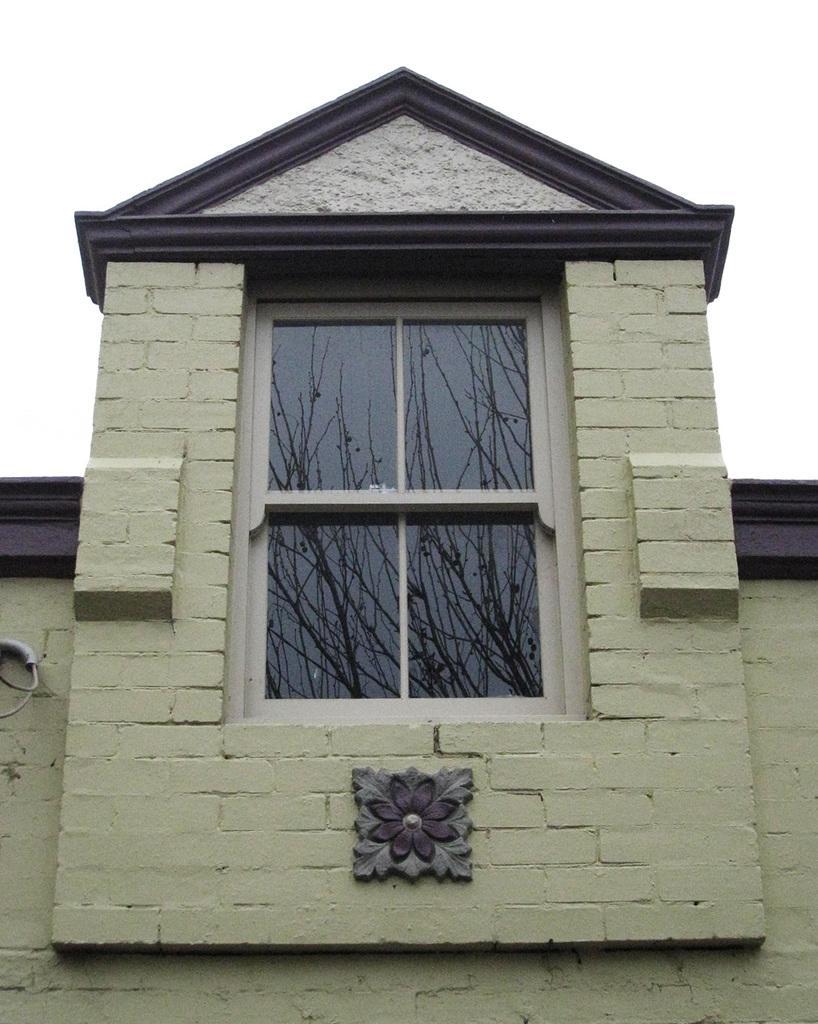Describe this image in one or two sentences. In the center of the image we can see a building, window, glass, carving on the wall, pipe, wires. Through glass we can see the reflection of the trees. At the top of the image we can see the sky. 